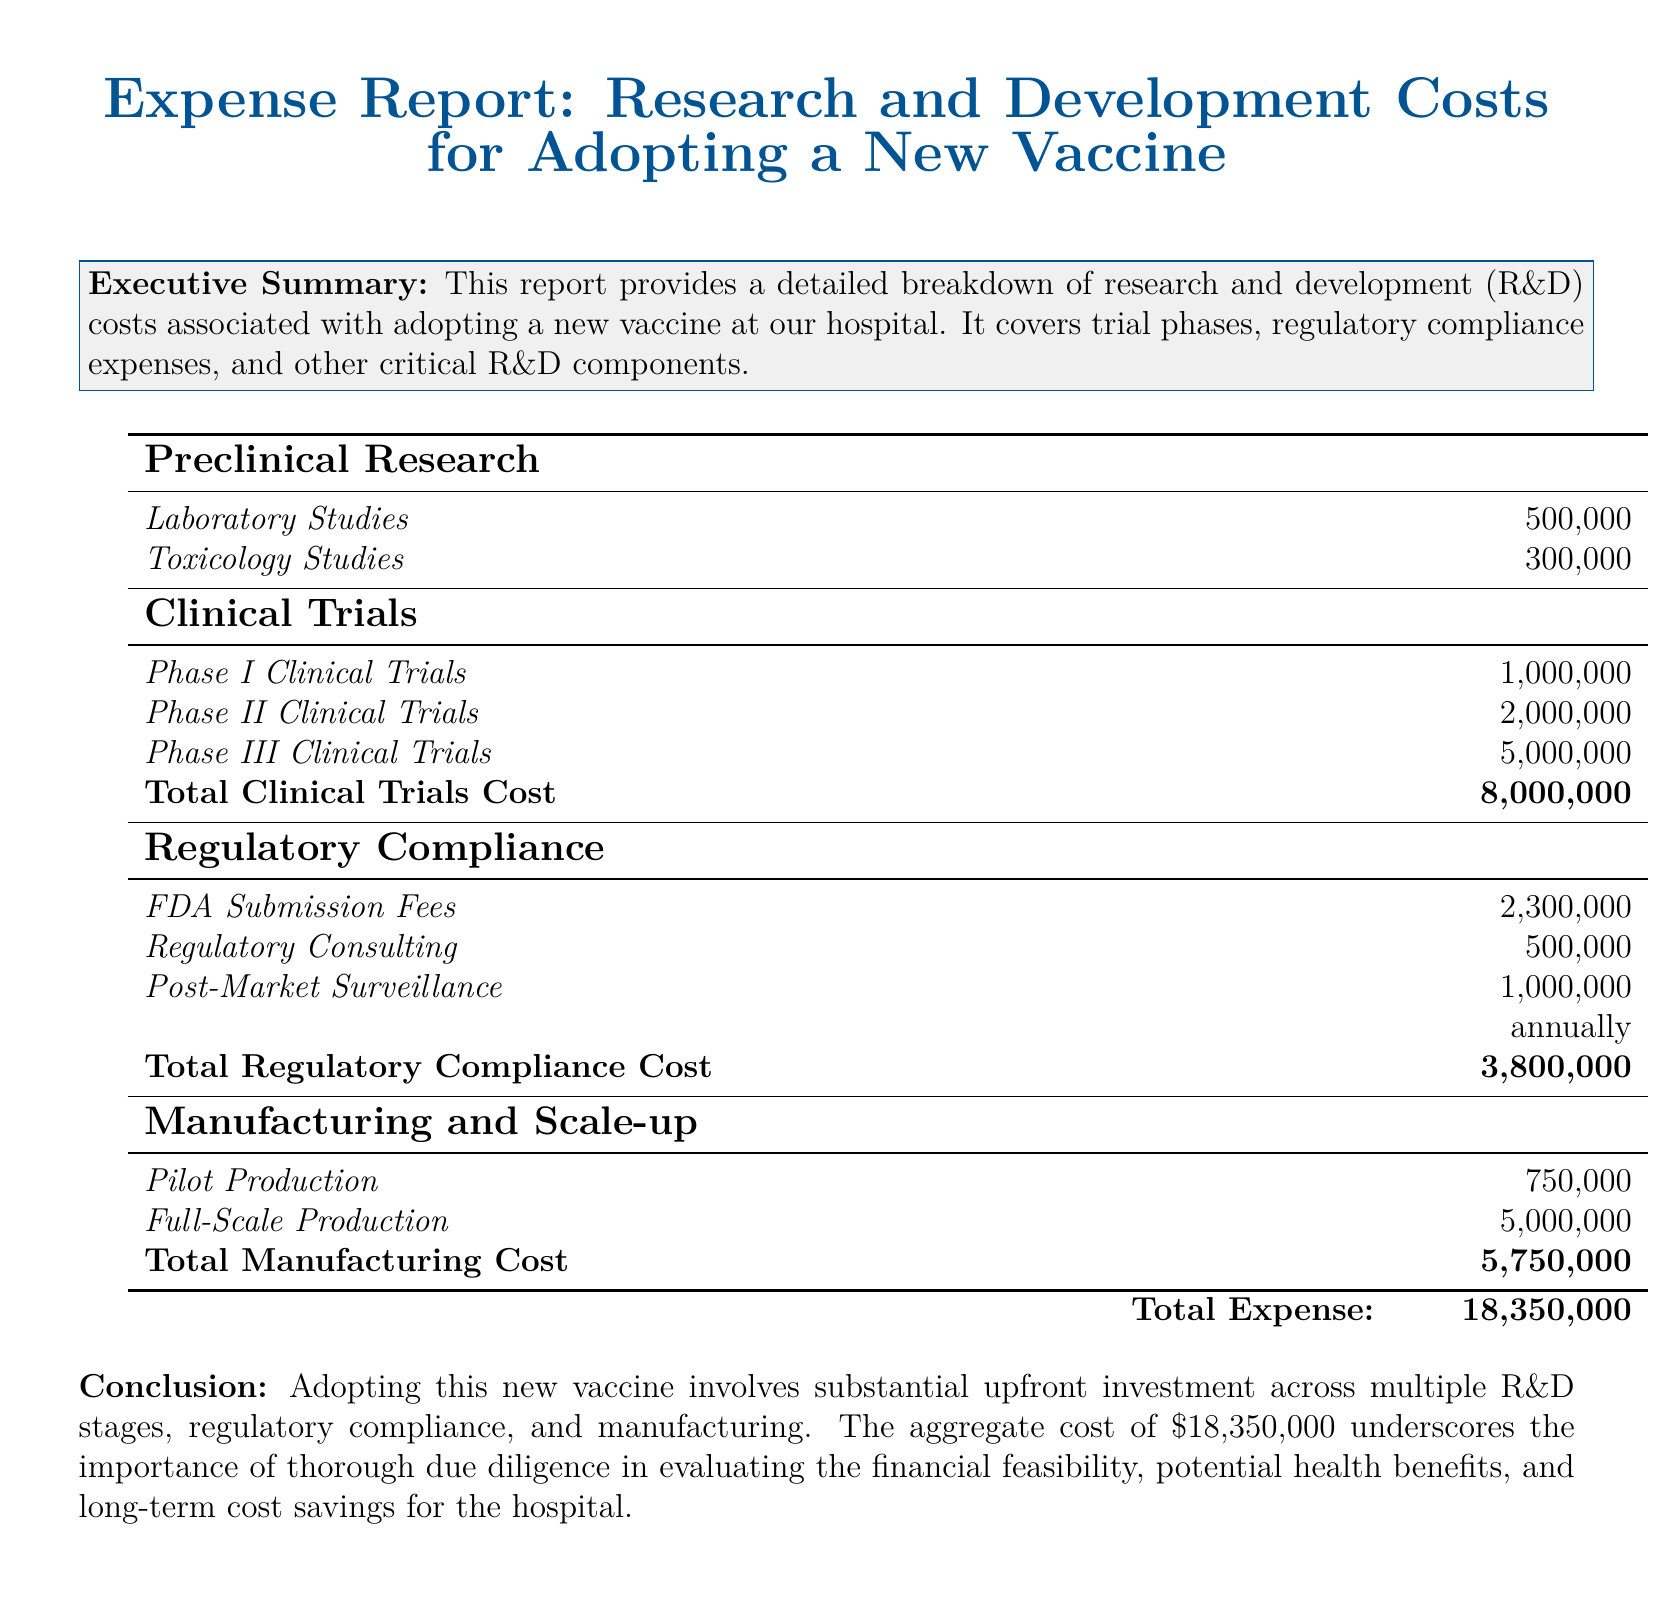What is the total cost of preclinical research? The total cost of preclinical research is the sum of laboratory and toxicology studies, which is 500,000 + 300,000.
Answer: 800,000 What is the cost for Phase II clinical trials? The document lists the cost for Phase II clinical trials explicitly as 2,000,000.
Answer: 2,000,000 What are the post-market surveillance costs? Post-market surveillance costs are indicated as an annual expense of 1,000,000.
Answer: 1,000,000 annually What is the total expense listed in the report? The document states the total expense at the bottom as 18,350,000, which summarizes all previously listed costs.
Answer: 18,350,000 What phase has the highest expense? By comparing the costs of clinical trials, Phase III clinical trials have the highest expense listed at 5,000,000.
Answer: Phase III Clinical Trials How much is allocated for regulatory consulting? The document mentions the specific cost for regulatory consulting as 500,000.
Answer: 500,000 What is the cost of full-scale production? Full-scale production cost is provided explicitly as 5,000,000 in the manufacturing section.
Answer: 5,000,000 What is the total cost associated with clinical trials? The report summarizes total clinical trials cost as the sum of all trial phases, which equals 8,000,000.
Answer: 8,000,000 What type of report is this? This is an expense report specifically created to outline costs related to the adoption of a new vaccine.
Answer: Expense Report 